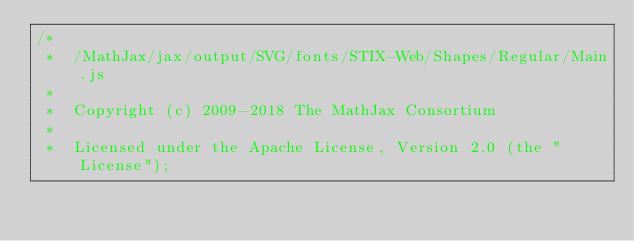<code> <loc_0><loc_0><loc_500><loc_500><_JavaScript_>/*
 *  /MathJax/jax/output/SVG/fonts/STIX-Web/Shapes/Regular/Main.js
 *
 *  Copyright (c) 2009-2018 The MathJax Consortium
 *
 *  Licensed under the Apache License, Version 2.0 (the "License");</code> 